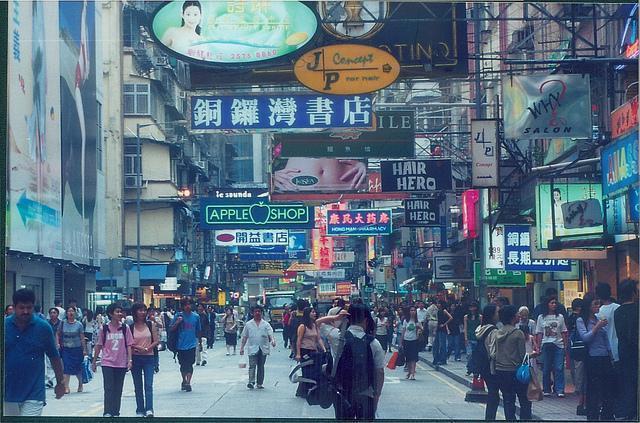How many people are in the photo?
Give a very brief answer. 5. How many white trucks are there in the image ?
Give a very brief answer. 0. 